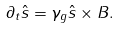Convert formula to latex. <formula><loc_0><loc_0><loc_500><loc_500>\partial _ { t } { \hat { s } } = \gamma _ { g } { \hat { s } } \times { B } .</formula> 